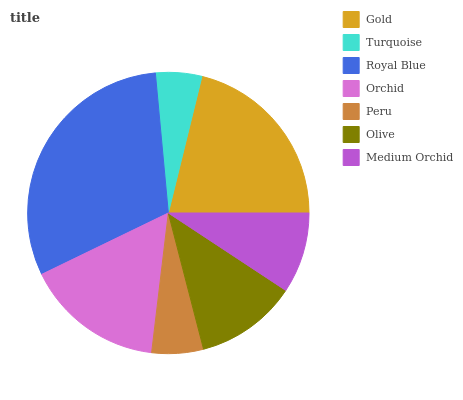Is Turquoise the minimum?
Answer yes or no. Yes. Is Royal Blue the maximum?
Answer yes or no. Yes. Is Royal Blue the minimum?
Answer yes or no. No. Is Turquoise the maximum?
Answer yes or no. No. Is Royal Blue greater than Turquoise?
Answer yes or no. Yes. Is Turquoise less than Royal Blue?
Answer yes or no. Yes. Is Turquoise greater than Royal Blue?
Answer yes or no. No. Is Royal Blue less than Turquoise?
Answer yes or no. No. Is Olive the high median?
Answer yes or no. Yes. Is Olive the low median?
Answer yes or no. Yes. Is Medium Orchid the high median?
Answer yes or no. No. Is Turquoise the low median?
Answer yes or no. No. 